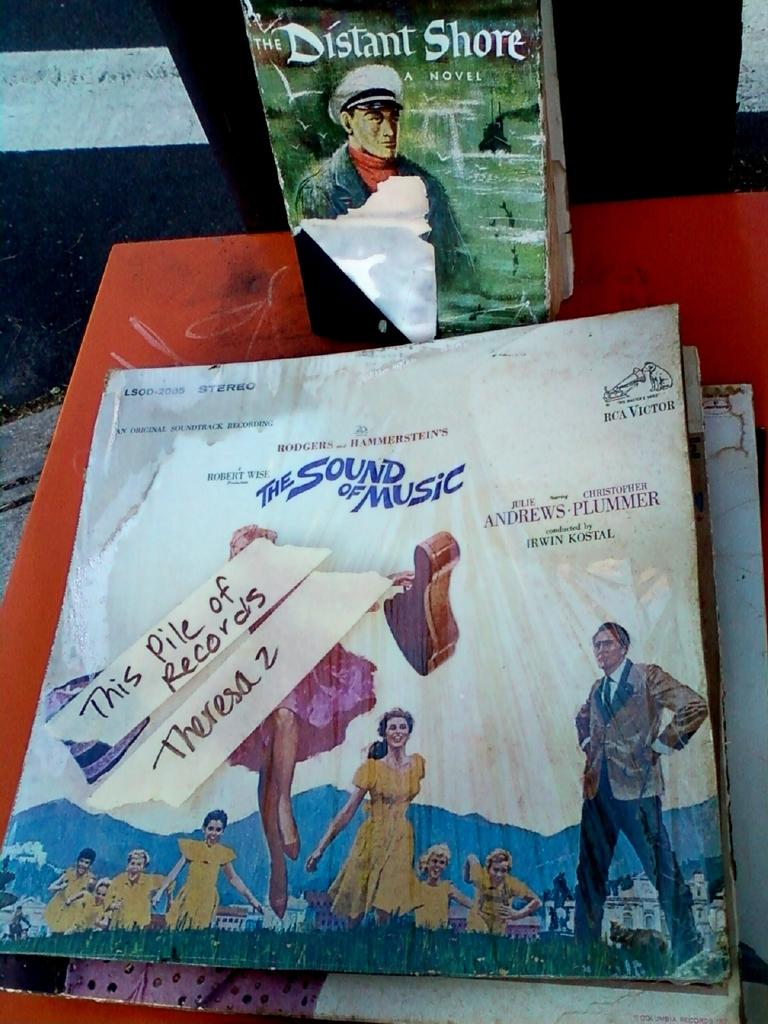What items can be seen on the table in the image? There are music covers and books on the table in the image. What is the main piece of furniture in the image? There is a table in the image. Are there any images of people in the image? Yes, there are people printed on the table. What type of design can be seen on the pump in the image? There is no pump present in the image. What kind of noise is being made by the people in the image? There are no people in the image, only printed images of people on the table. 